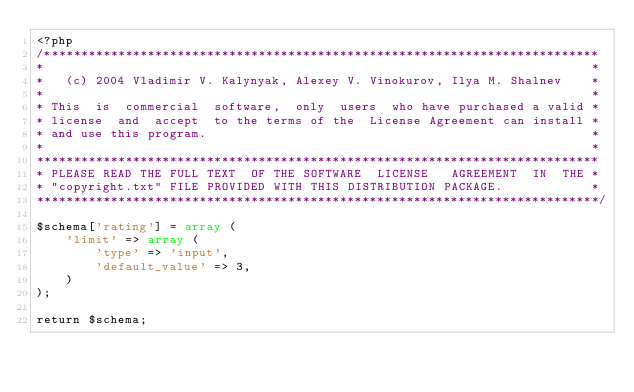Convert code to text. <code><loc_0><loc_0><loc_500><loc_500><_PHP_><?php
/***************************************************************************
*                                                                          *
*   (c) 2004 Vladimir V. Kalynyak, Alexey V. Vinokurov, Ilya M. Shalnev    *
*                                                                          *
* This  is  commercial  software,  only  users  who have purchased a valid *
* license  and  accept  to the terms of the  License Agreement can install *
* and use this program.                                                    *
*                                                                          *
****************************************************************************
* PLEASE READ THE FULL TEXT  OF THE SOFTWARE  LICENSE   AGREEMENT  IN  THE *
* "copyright.txt" FILE PROVIDED WITH THIS DISTRIBUTION PACKAGE.            *
****************************************************************************/

$schema['rating'] = array (
    'limit' => array (
        'type' => 'input',
        'default_value' => 3,
    )
);

return $schema;
</code> 